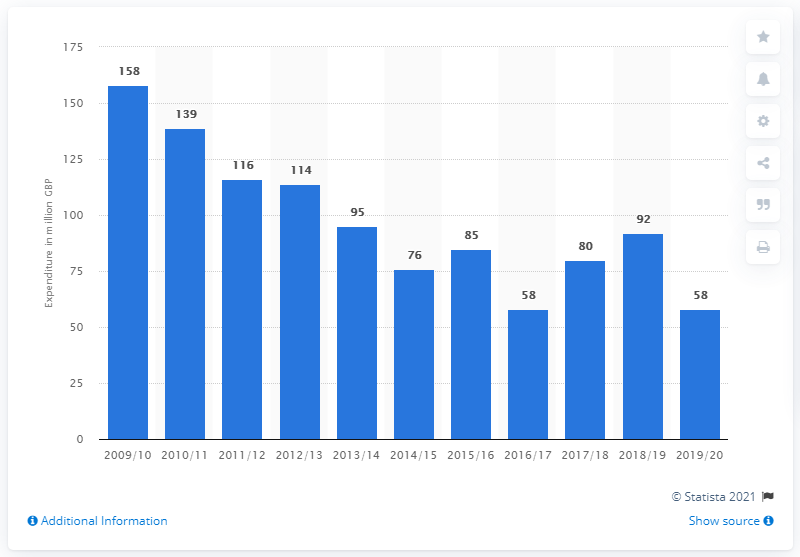Point out several critical features in this image. The UK government spent approximately 58 billion pounds on religious and community services in the 2019/20 fiscal year. The United Kingdom spent approximately 92 pounds on religious and community services in the previous year. 